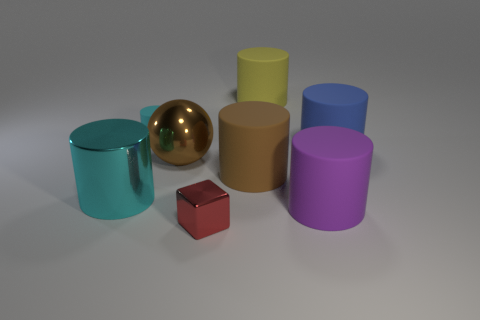Subtract all large blue matte cylinders. How many cylinders are left? 5 Add 1 blue rubber balls. How many objects exist? 9 Subtract all yellow blocks. How many cyan cylinders are left? 2 Subtract all brown cylinders. How many cylinders are left? 5 Add 2 big brown balls. How many big brown balls are left? 3 Add 5 gray matte balls. How many gray matte balls exist? 5 Subtract 0 brown cubes. How many objects are left? 8 Subtract all balls. How many objects are left? 7 Subtract all red cylinders. Subtract all blue balls. How many cylinders are left? 6 Subtract all red rubber cylinders. Subtract all cyan cylinders. How many objects are left? 6 